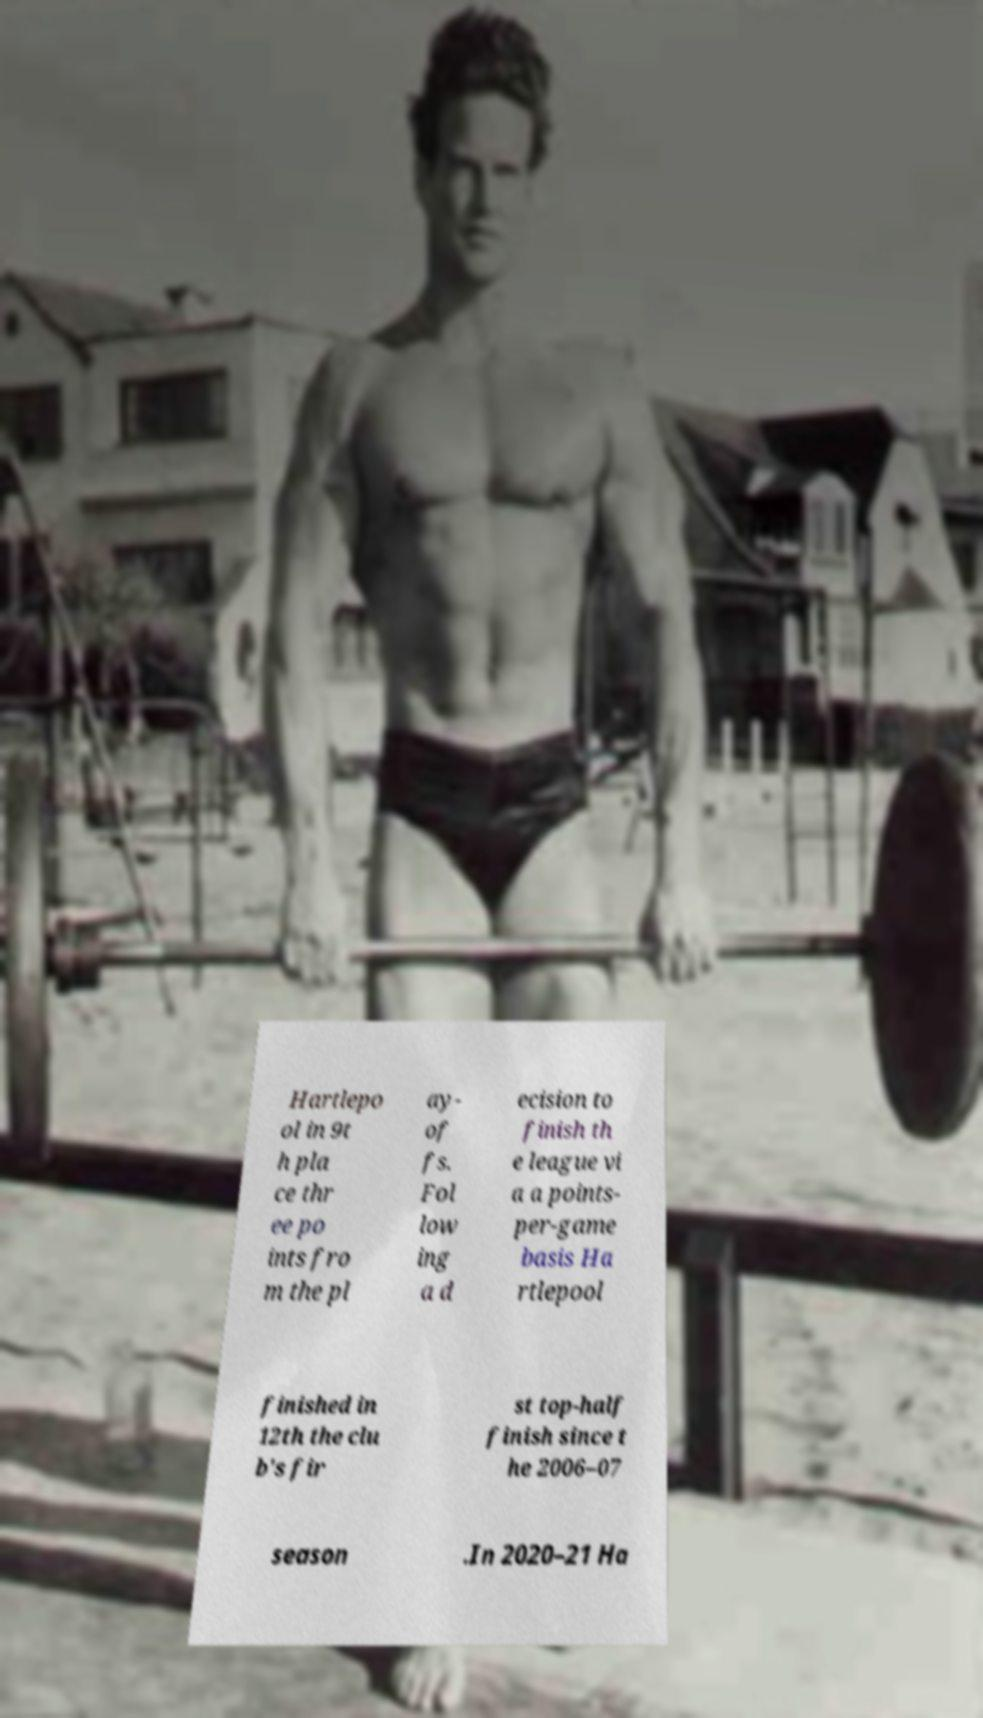Please read and relay the text visible in this image. What does it say? Hartlepo ol in 9t h pla ce thr ee po ints fro m the pl ay- of fs. Fol low ing a d ecision to finish th e league vi a a points- per-game basis Ha rtlepool finished in 12th the clu b's fir st top-half finish since t he 2006–07 season .In 2020–21 Ha 